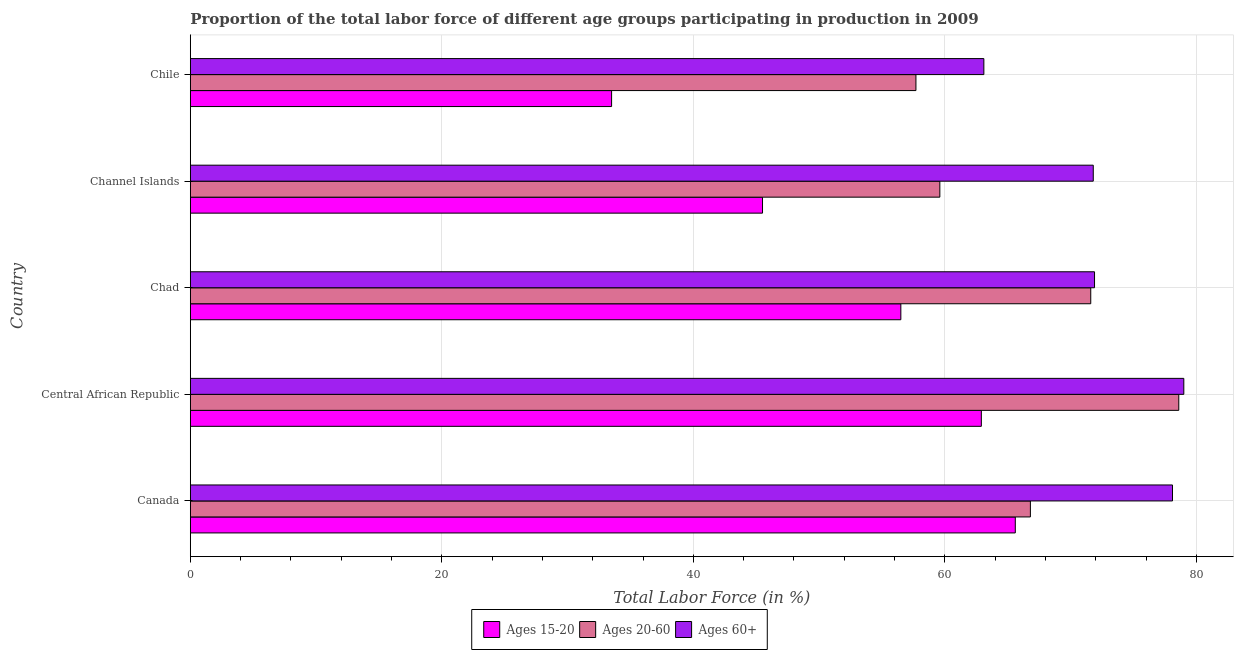How many different coloured bars are there?
Provide a succinct answer. 3. How many groups of bars are there?
Make the answer very short. 5. Are the number of bars per tick equal to the number of legend labels?
Provide a short and direct response. Yes. How many bars are there on the 4th tick from the top?
Keep it short and to the point. 3. What is the label of the 3rd group of bars from the top?
Your response must be concise. Chad. What is the percentage of labor force within the age group 15-20 in Canada?
Provide a short and direct response. 65.6. Across all countries, what is the maximum percentage of labor force within the age group 20-60?
Keep it short and to the point. 78.6. Across all countries, what is the minimum percentage of labor force above age 60?
Your answer should be compact. 63.1. In which country was the percentage of labor force within the age group 20-60 maximum?
Your answer should be compact. Central African Republic. In which country was the percentage of labor force within the age group 15-20 minimum?
Provide a short and direct response. Chile. What is the total percentage of labor force above age 60 in the graph?
Give a very brief answer. 363.9. What is the difference between the percentage of labor force above age 60 in Canada and that in Central African Republic?
Provide a short and direct response. -0.9. What is the difference between the percentage of labor force within the age group 20-60 in Canada and the percentage of labor force above age 60 in Chad?
Give a very brief answer. -5.1. What is the average percentage of labor force within the age group 15-20 per country?
Your answer should be compact. 52.8. What is the difference between the percentage of labor force within the age group 15-20 and percentage of labor force within the age group 20-60 in Channel Islands?
Ensure brevity in your answer.  -14.1. What is the ratio of the percentage of labor force within the age group 15-20 in Chad to that in Chile?
Your answer should be very brief. 1.69. Is the percentage of labor force within the age group 20-60 in Chad less than that in Channel Islands?
Your response must be concise. No. What is the difference between the highest and the lowest percentage of labor force above age 60?
Your answer should be very brief. 15.9. Is the sum of the percentage of labor force within the age group 20-60 in Canada and Chad greater than the maximum percentage of labor force above age 60 across all countries?
Keep it short and to the point. Yes. What does the 2nd bar from the top in Canada represents?
Your response must be concise. Ages 20-60. What does the 2nd bar from the bottom in Channel Islands represents?
Your response must be concise. Ages 20-60. Is it the case that in every country, the sum of the percentage of labor force within the age group 15-20 and percentage of labor force within the age group 20-60 is greater than the percentage of labor force above age 60?
Provide a succinct answer. Yes. How many bars are there?
Ensure brevity in your answer.  15. Are the values on the major ticks of X-axis written in scientific E-notation?
Keep it short and to the point. No. Does the graph contain any zero values?
Your response must be concise. No. Does the graph contain grids?
Make the answer very short. Yes. How many legend labels are there?
Provide a succinct answer. 3. What is the title of the graph?
Give a very brief answer. Proportion of the total labor force of different age groups participating in production in 2009. What is the Total Labor Force (in %) in Ages 15-20 in Canada?
Keep it short and to the point. 65.6. What is the Total Labor Force (in %) of Ages 20-60 in Canada?
Your response must be concise. 66.8. What is the Total Labor Force (in %) in Ages 60+ in Canada?
Offer a terse response. 78.1. What is the Total Labor Force (in %) in Ages 15-20 in Central African Republic?
Offer a very short reply. 62.9. What is the Total Labor Force (in %) of Ages 20-60 in Central African Republic?
Provide a succinct answer. 78.6. What is the Total Labor Force (in %) in Ages 60+ in Central African Republic?
Make the answer very short. 79. What is the Total Labor Force (in %) in Ages 15-20 in Chad?
Give a very brief answer. 56.5. What is the Total Labor Force (in %) in Ages 20-60 in Chad?
Make the answer very short. 71.6. What is the Total Labor Force (in %) of Ages 60+ in Chad?
Your answer should be very brief. 71.9. What is the Total Labor Force (in %) of Ages 15-20 in Channel Islands?
Offer a terse response. 45.5. What is the Total Labor Force (in %) in Ages 20-60 in Channel Islands?
Keep it short and to the point. 59.6. What is the Total Labor Force (in %) of Ages 60+ in Channel Islands?
Your response must be concise. 71.8. What is the Total Labor Force (in %) in Ages 15-20 in Chile?
Provide a succinct answer. 33.5. What is the Total Labor Force (in %) of Ages 20-60 in Chile?
Your response must be concise. 57.7. What is the Total Labor Force (in %) of Ages 60+ in Chile?
Give a very brief answer. 63.1. Across all countries, what is the maximum Total Labor Force (in %) of Ages 15-20?
Offer a very short reply. 65.6. Across all countries, what is the maximum Total Labor Force (in %) in Ages 20-60?
Make the answer very short. 78.6. Across all countries, what is the maximum Total Labor Force (in %) of Ages 60+?
Provide a succinct answer. 79. Across all countries, what is the minimum Total Labor Force (in %) in Ages 15-20?
Give a very brief answer. 33.5. Across all countries, what is the minimum Total Labor Force (in %) of Ages 20-60?
Make the answer very short. 57.7. Across all countries, what is the minimum Total Labor Force (in %) in Ages 60+?
Provide a short and direct response. 63.1. What is the total Total Labor Force (in %) of Ages 15-20 in the graph?
Ensure brevity in your answer.  264. What is the total Total Labor Force (in %) in Ages 20-60 in the graph?
Offer a terse response. 334.3. What is the total Total Labor Force (in %) in Ages 60+ in the graph?
Provide a succinct answer. 363.9. What is the difference between the Total Labor Force (in %) in Ages 20-60 in Canada and that in Central African Republic?
Make the answer very short. -11.8. What is the difference between the Total Labor Force (in %) in Ages 20-60 in Canada and that in Chad?
Keep it short and to the point. -4.8. What is the difference between the Total Labor Force (in %) in Ages 15-20 in Canada and that in Channel Islands?
Offer a terse response. 20.1. What is the difference between the Total Labor Force (in %) of Ages 20-60 in Canada and that in Channel Islands?
Provide a short and direct response. 7.2. What is the difference between the Total Labor Force (in %) of Ages 15-20 in Canada and that in Chile?
Provide a succinct answer. 32.1. What is the difference between the Total Labor Force (in %) of Ages 60+ in Central African Republic and that in Chad?
Your answer should be very brief. 7.1. What is the difference between the Total Labor Force (in %) in Ages 60+ in Central African Republic and that in Channel Islands?
Ensure brevity in your answer.  7.2. What is the difference between the Total Labor Force (in %) of Ages 15-20 in Central African Republic and that in Chile?
Give a very brief answer. 29.4. What is the difference between the Total Labor Force (in %) of Ages 20-60 in Central African Republic and that in Chile?
Your answer should be very brief. 20.9. What is the difference between the Total Labor Force (in %) in Ages 60+ in Central African Republic and that in Chile?
Offer a very short reply. 15.9. What is the difference between the Total Labor Force (in %) in Ages 60+ in Chad and that in Channel Islands?
Your response must be concise. 0.1. What is the difference between the Total Labor Force (in %) in Ages 15-20 in Chad and that in Chile?
Provide a succinct answer. 23. What is the difference between the Total Labor Force (in %) in Ages 60+ in Channel Islands and that in Chile?
Make the answer very short. 8.7. What is the difference between the Total Labor Force (in %) of Ages 15-20 in Canada and the Total Labor Force (in %) of Ages 60+ in Central African Republic?
Keep it short and to the point. -13.4. What is the difference between the Total Labor Force (in %) in Ages 20-60 in Canada and the Total Labor Force (in %) in Ages 60+ in Central African Republic?
Ensure brevity in your answer.  -12.2. What is the difference between the Total Labor Force (in %) of Ages 15-20 in Canada and the Total Labor Force (in %) of Ages 60+ in Chad?
Ensure brevity in your answer.  -6.3. What is the difference between the Total Labor Force (in %) in Ages 15-20 in Canada and the Total Labor Force (in %) in Ages 60+ in Channel Islands?
Offer a very short reply. -6.2. What is the difference between the Total Labor Force (in %) in Ages 20-60 in Canada and the Total Labor Force (in %) in Ages 60+ in Channel Islands?
Your response must be concise. -5. What is the difference between the Total Labor Force (in %) in Ages 15-20 in Central African Republic and the Total Labor Force (in %) in Ages 60+ in Chad?
Offer a very short reply. -9. What is the difference between the Total Labor Force (in %) in Ages 20-60 in Central African Republic and the Total Labor Force (in %) in Ages 60+ in Chad?
Make the answer very short. 6.7. What is the difference between the Total Labor Force (in %) in Ages 15-20 in Central African Republic and the Total Labor Force (in %) in Ages 20-60 in Chile?
Ensure brevity in your answer.  5.2. What is the difference between the Total Labor Force (in %) in Ages 15-20 in Central African Republic and the Total Labor Force (in %) in Ages 60+ in Chile?
Your answer should be compact. -0.2. What is the difference between the Total Labor Force (in %) in Ages 20-60 in Central African Republic and the Total Labor Force (in %) in Ages 60+ in Chile?
Ensure brevity in your answer.  15.5. What is the difference between the Total Labor Force (in %) of Ages 15-20 in Chad and the Total Labor Force (in %) of Ages 60+ in Channel Islands?
Your answer should be very brief. -15.3. What is the difference between the Total Labor Force (in %) in Ages 20-60 in Chad and the Total Labor Force (in %) in Ages 60+ in Channel Islands?
Your answer should be compact. -0.2. What is the difference between the Total Labor Force (in %) in Ages 15-20 in Chad and the Total Labor Force (in %) in Ages 60+ in Chile?
Your response must be concise. -6.6. What is the difference between the Total Labor Force (in %) in Ages 20-60 in Chad and the Total Labor Force (in %) in Ages 60+ in Chile?
Offer a terse response. 8.5. What is the difference between the Total Labor Force (in %) of Ages 15-20 in Channel Islands and the Total Labor Force (in %) of Ages 60+ in Chile?
Offer a terse response. -17.6. What is the difference between the Total Labor Force (in %) in Ages 20-60 in Channel Islands and the Total Labor Force (in %) in Ages 60+ in Chile?
Your response must be concise. -3.5. What is the average Total Labor Force (in %) of Ages 15-20 per country?
Provide a short and direct response. 52.8. What is the average Total Labor Force (in %) in Ages 20-60 per country?
Give a very brief answer. 66.86. What is the average Total Labor Force (in %) of Ages 60+ per country?
Provide a short and direct response. 72.78. What is the difference between the Total Labor Force (in %) in Ages 15-20 and Total Labor Force (in %) in Ages 20-60 in Canada?
Your response must be concise. -1.2. What is the difference between the Total Labor Force (in %) in Ages 15-20 and Total Labor Force (in %) in Ages 60+ in Canada?
Provide a short and direct response. -12.5. What is the difference between the Total Labor Force (in %) in Ages 20-60 and Total Labor Force (in %) in Ages 60+ in Canada?
Your answer should be very brief. -11.3. What is the difference between the Total Labor Force (in %) in Ages 15-20 and Total Labor Force (in %) in Ages 20-60 in Central African Republic?
Provide a short and direct response. -15.7. What is the difference between the Total Labor Force (in %) in Ages 15-20 and Total Labor Force (in %) in Ages 60+ in Central African Republic?
Keep it short and to the point. -16.1. What is the difference between the Total Labor Force (in %) of Ages 15-20 and Total Labor Force (in %) of Ages 20-60 in Chad?
Offer a very short reply. -15.1. What is the difference between the Total Labor Force (in %) of Ages 15-20 and Total Labor Force (in %) of Ages 60+ in Chad?
Offer a terse response. -15.4. What is the difference between the Total Labor Force (in %) of Ages 20-60 and Total Labor Force (in %) of Ages 60+ in Chad?
Provide a short and direct response. -0.3. What is the difference between the Total Labor Force (in %) of Ages 15-20 and Total Labor Force (in %) of Ages 20-60 in Channel Islands?
Your response must be concise. -14.1. What is the difference between the Total Labor Force (in %) of Ages 15-20 and Total Labor Force (in %) of Ages 60+ in Channel Islands?
Your answer should be very brief. -26.3. What is the difference between the Total Labor Force (in %) in Ages 15-20 and Total Labor Force (in %) in Ages 20-60 in Chile?
Keep it short and to the point. -24.2. What is the difference between the Total Labor Force (in %) of Ages 15-20 and Total Labor Force (in %) of Ages 60+ in Chile?
Give a very brief answer. -29.6. What is the ratio of the Total Labor Force (in %) in Ages 15-20 in Canada to that in Central African Republic?
Your answer should be compact. 1.04. What is the ratio of the Total Labor Force (in %) of Ages 20-60 in Canada to that in Central African Republic?
Your answer should be compact. 0.85. What is the ratio of the Total Labor Force (in %) in Ages 60+ in Canada to that in Central African Republic?
Give a very brief answer. 0.99. What is the ratio of the Total Labor Force (in %) in Ages 15-20 in Canada to that in Chad?
Your response must be concise. 1.16. What is the ratio of the Total Labor Force (in %) in Ages 20-60 in Canada to that in Chad?
Give a very brief answer. 0.93. What is the ratio of the Total Labor Force (in %) in Ages 60+ in Canada to that in Chad?
Provide a short and direct response. 1.09. What is the ratio of the Total Labor Force (in %) of Ages 15-20 in Canada to that in Channel Islands?
Ensure brevity in your answer.  1.44. What is the ratio of the Total Labor Force (in %) in Ages 20-60 in Canada to that in Channel Islands?
Provide a short and direct response. 1.12. What is the ratio of the Total Labor Force (in %) of Ages 60+ in Canada to that in Channel Islands?
Your response must be concise. 1.09. What is the ratio of the Total Labor Force (in %) of Ages 15-20 in Canada to that in Chile?
Your response must be concise. 1.96. What is the ratio of the Total Labor Force (in %) of Ages 20-60 in Canada to that in Chile?
Make the answer very short. 1.16. What is the ratio of the Total Labor Force (in %) in Ages 60+ in Canada to that in Chile?
Ensure brevity in your answer.  1.24. What is the ratio of the Total Labor Force (in %) in Ages 15-20 in Central African Republic to that in Chad?
Offer a very short reply. 1.11. What is the ratio of the Total Labor Force (in %) of Ages 20-60 in Central African Republic to that in Chad?
Keep it short and to the point. 1.1. What is the ratio of the Total Labor Force (in %) in Ages 60+ in Central African Republic to that in Chad?
Your answer should be compact. 1.1. What is the ratio of the Total Labor Force (in %) of Ages 15-20 in Central African Republic to that in Channel Islands?
Provide a short and direct response. 1.38. What is the ratio of the Total Labor Force (in %) of Ages 20-60 in Central African Republic to that in Channel Islands?
Your response must be concise. 1.32. What is the ratio of the Total Labor Force (in %) of Ages 60+ in Central African Republic to that in Channel Islands?
Your answer should be compact. 1.1. What is the ratio of the Total Labor Force (in %) in Ages 15-20 in Central African Republic to that in Chile?
Your answer should be very brief. 1.88. What is the ratio of the Total Labor Force (in %) in Ages 20-60 in Central African Republic to that in Chile?
Ensure brevity in your answer.  1.36. What is the ratio of the Total Labor Force (in %) of Ages 60+ in Central African Republic to that in Chile?
Make the answer very short. 1.25. What is the ratio of the Total Labor Force (in %) of Ages 15-20 in Chad to that in Channel Islands?
Your answer should be compact. 1.24. What is the ratio of the Total Labor Force (in %) of Ages 20-60 in Chad to that in Channel Islands?
Give a very brief answer. 1.2. What is the ratio of the Total Labor Force (in %) of Ages 15-20 in Chad to that in Chile?
Offer a terse response. 1.69. What is the ratio of the Total Labor Force (in %) of Ages 20-60 in Chad to that in Chile?
Your answer should be very brief. 1.24. What is the ratio of the Total Labor Force (in %) in Ages 60+ in Chad to that in Chile?
Make the answer very short. 1.14. What is the ratio of the Total Labor Force (in %) in Ages 15-20 in Channel Islands to that in Chile?
Provide a succinct answer. 1.36. What is the ratio of the Total Labor Force (in %) in Ages 20-60 in Channel Islands to that in Chile?
Keep it short and to the point. 1.03. What is the ratio of the Total Labor Force (in %) of Ages 60+ in Channel Islands to that in Chile?
Offer a very short reply. 1.14. What is the difference between the highest and the second highest Total Labor Force (in %) in Ages 15-20?
Your answer should be very brief. 2.7. What is the difference between the highest and the lowest Total Labor Force (in %) of Ages 15-20?
Offer a very short reply. 32.1. What is the difference between the highest and the lowest Total Labor Force (in %) of Ages 20-60?
Ensure brevity in your answer.  20.9. 